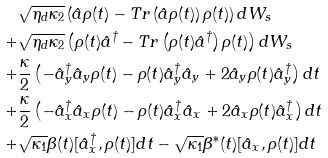<formula> <loc_0><loc_0><loc_500><loc_500>& \sqrt { \eta _ { d } \kappa _ { 2 } } \left ( \hat { a } \rho ( t ) - T r \left ( \hat { a } \rho ( t ) \right ) \rho ( t ) \right ) d W _ { s } \\ + & \sqrt { \eta _ { d } \kappa _ { 2 } } \left ( \rho ( t ) \hat { a } ^ { \dag } - T r \left ( \rho ( t ) \hat { a } ^ { \dag } \right ) \rho ( t ) \right ) d W _ { s } \\ + & \frac { \kappa } { 2 } \left ( - \hat { a } ^ { \dag } _ { y } \hat { a } _ { y } \rho ( t ) - \rho ( t ) \hat { a } ^ { \dag } _ { y } \hat { a } _ { y } + 2 \hat { a } _ { y } \rho ( t ) \hat { a } _ { y } ^ { \dag } \right ) d t \\ + & \frac { \kappa } { 2 } \left ( - \hat { a } ^ { \dag } _ { x } \hat { a } _ { x } \rho ( t ) - \rho ( t ) \hat { a } ^ { \dag } _ { x } \hat { a } _ { x } + 2 \hat { a } _ { x } \rho ( t ) \hat { a } _ { x } ^ { \dag } \right ) d t \\ + & \sqrt { \kappa _ { 1 } } \beta ( t ) [ \hat { a } _ { x } ^ { \dag } , \rho ( t ) ] d t - \sqrt { \kappa _ { 1 } } \beta ^ { * } ( t ) [ \hat { a } _ { x } , \rho ( t ) ] d t</formula> 